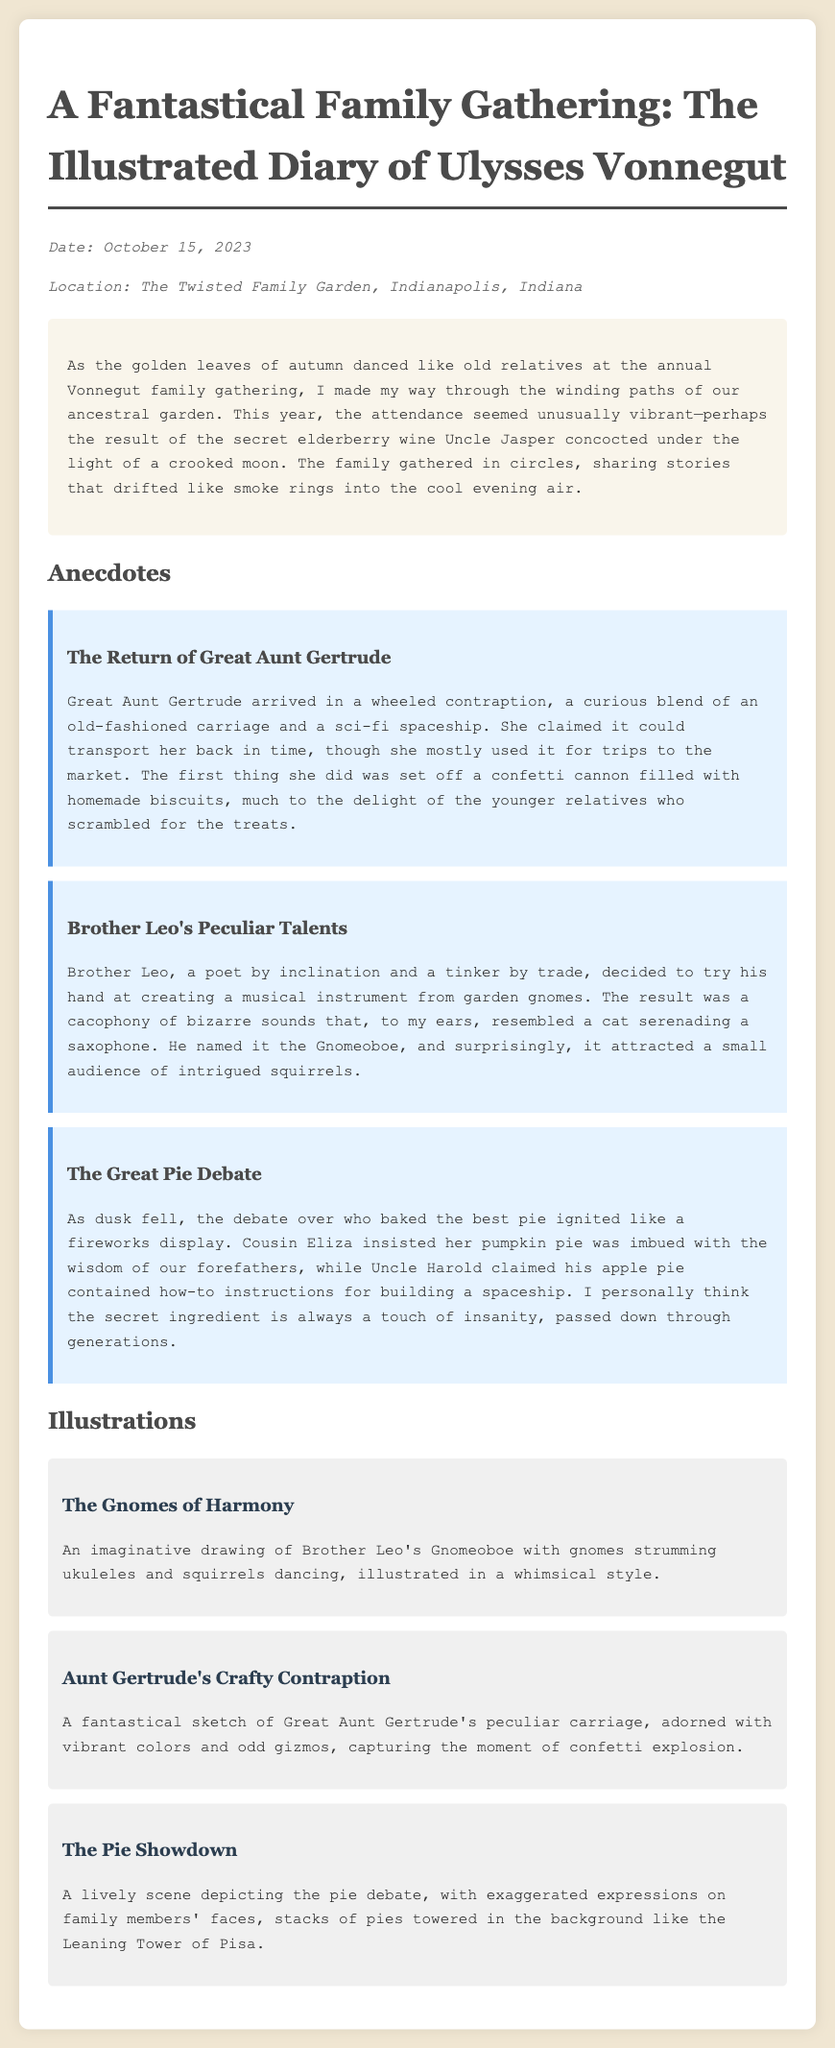What is the date of the gathering? The date is mentioned in the meta section of the document.
Answer: October 15, 2023 Where was the gathering held? The location is also specified in the meta section.
Answer: The Twisted Family Garden, Indianapolis, Indiana Who arrived in a wheeled contraption? This detail is provided in the anecdote about Great Aunt Gertrude.
Answer: Great Aunt Gertrude What is the name of Brother Leo's invention? The name is mentioned in the anecdote discussing his creation.
Answer: Gnomeoboe Which pie did Cousin Eliza claim was the best? The pie in question is noted in the anecdote about the pie debate.
Answer: Pumpkin pie What kind of drink influenced the gathering's atmosphere? The drink is referenced as a reason for the vibrant attendance at the gathering.
Answer: Elderberry wine What peculiar event did Great Aunt Gertrude cause? The event is described in her anecdote regarding her arrival.
Answer: Confetti explosion How many illustrations are included in the document? The total number of illustrations is mentioned in the section heading.
Answer: Three 